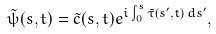Convert formula to latex. <formula><loc_0><loc_0><loc_500><loc_500>\tilde { \psi } ( s , t ) = \tilde { c } ( s , t ) e ^ { i \int _ { 0 } ^ { s } \tilde { \tau } ( s ^ { \prime } , t ) \, d s ^ { \prime } } ,</formula> 